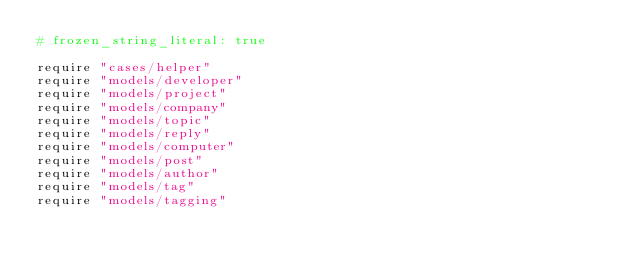<code> <loc_0><loc_0><loc_500><loc_500><_Ruby_># frozen_string_literal: true

require "cases/helper"
require "models/developer"
require "models/project"
require "models/company"
require "models/topic"
require "models/reply"
require "models/computer"
require "models/post"
require "models/author"
require "models/tag"
require "models/tagging"</code> 